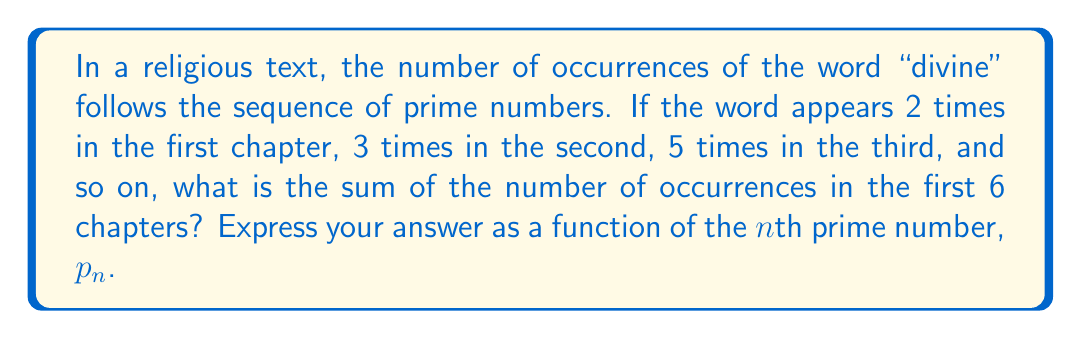Teach me how to tackle this problem. Let's approach this step-by-step:

1) First, recall that the sequence of prime numbers starts with:
   2, 3, 5, 7, 11, 13, ...

2) In our problem, the number of occurrences in each chapter follows this sequence:
   Chapter 1: 2 occurrences
   Chapter 2: 3 occurrences
   Chapter 3: 5 occurrences
   Chapter 4: 7 occurrences
   Chapter 5: 11 occurrences
   Chapter 6: 13 occurrences

3) To find the sum of these occurrences, we need to add these numbers:
   $$2 + 3 + 5 + 7 + 11 + 13$$

4) This sum can be expressed using the notation for the nth prime number, $p_n$:
   $$p_1 + p_2 + p_3 + p_4 + p_5 + p_6$$

5) In number theory, the sum of the first n prime numbers is often denoted as:
   $$\sum_{i=1}^n p_i$$

6) Therefore, our sum can be written as:
   $$\sum_{i=1}^6 p_i$$

This expression represents the sum of the first 6 prime numbers, which is exactly what we're looking for in this problem.
Answer: $$\sum_{i=1}^6 p_i$$ 